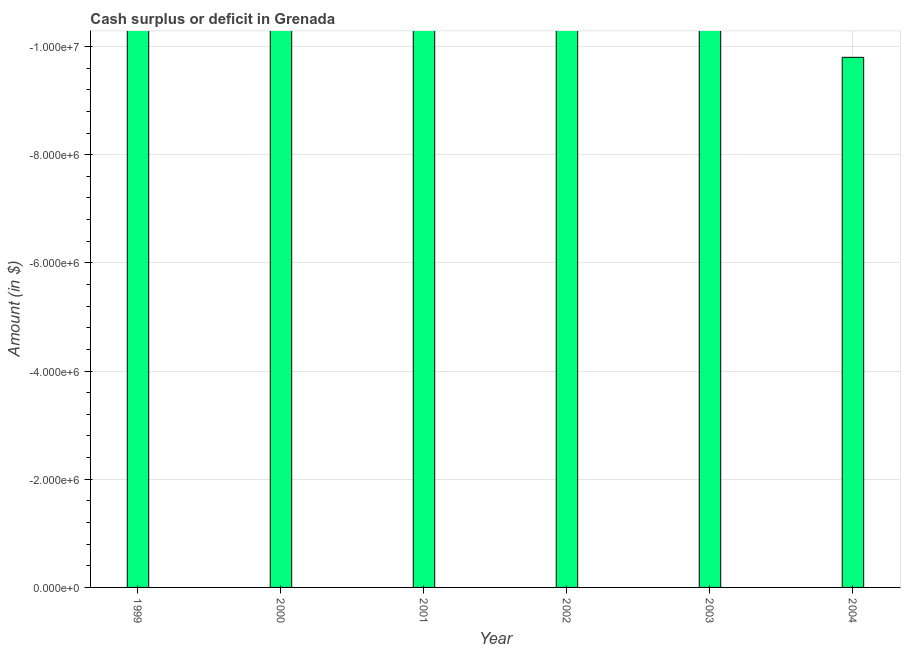Does the graph contain grids?
Offer a terse response. Yes. What is the title of the graph?
Ensure brevity in your answer.  Cash surplus or deficit in Grenada. What is the label or title of the X-axis?
Provide a succinct answer. Year. What is the label or title of the Y-axis?
Offer a terse response. Amount (in $). What is the average cash surplus or deficit per year?
Ensure brevity in your answer.  0. What is the median cash surplus or deficit?
Make the answer very short. 0. What is the Amount (in $) in 2003?
Provide a succinct answer. 0. What is the Amount (in $) in 2004?
Keep it short and to the point. 0. 